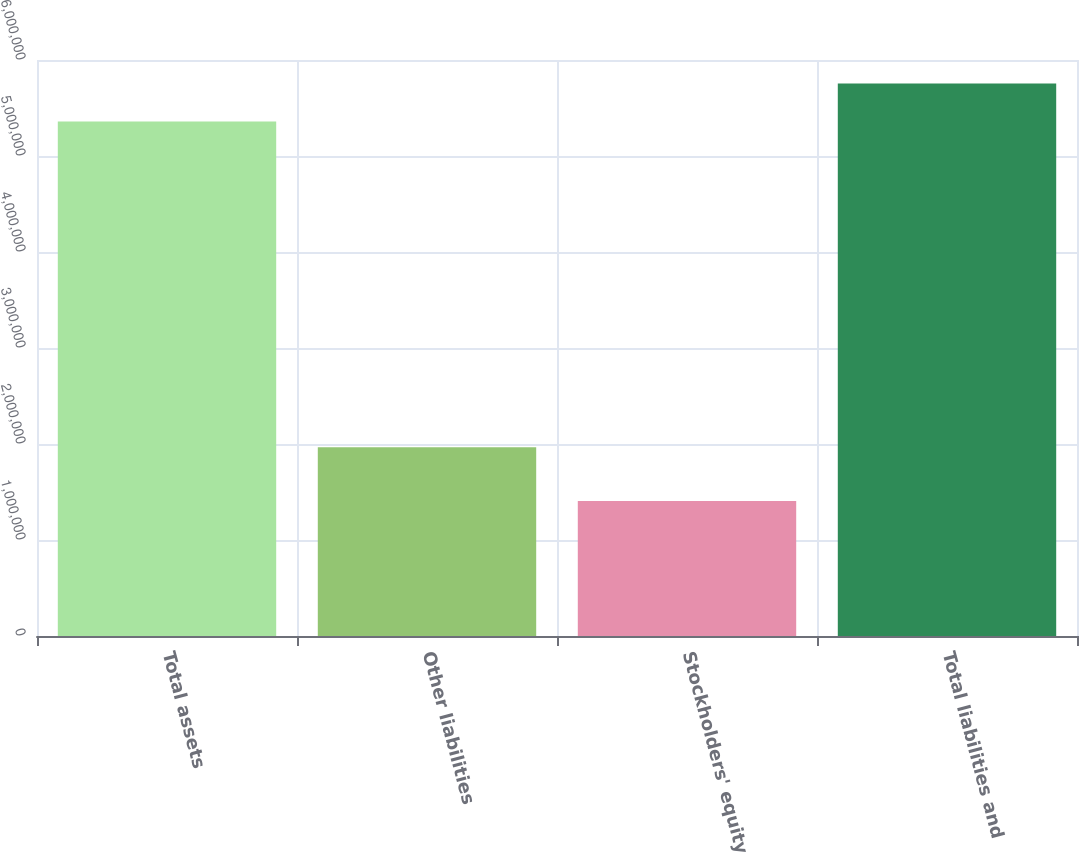Convert chart to OTSL. <chart><loc_0><loc_0><loc_500><loc_500><bar_chart><fcel>Total assets<fcel>Other liabilities<fcel>Stockholders' equity<fcel>Total liabilities and<nl><fcel>5.35972e+06<fcel>1.96685e+06<fcel>1.40586e+06<fcel>5.75511e+06<nl></chart> 